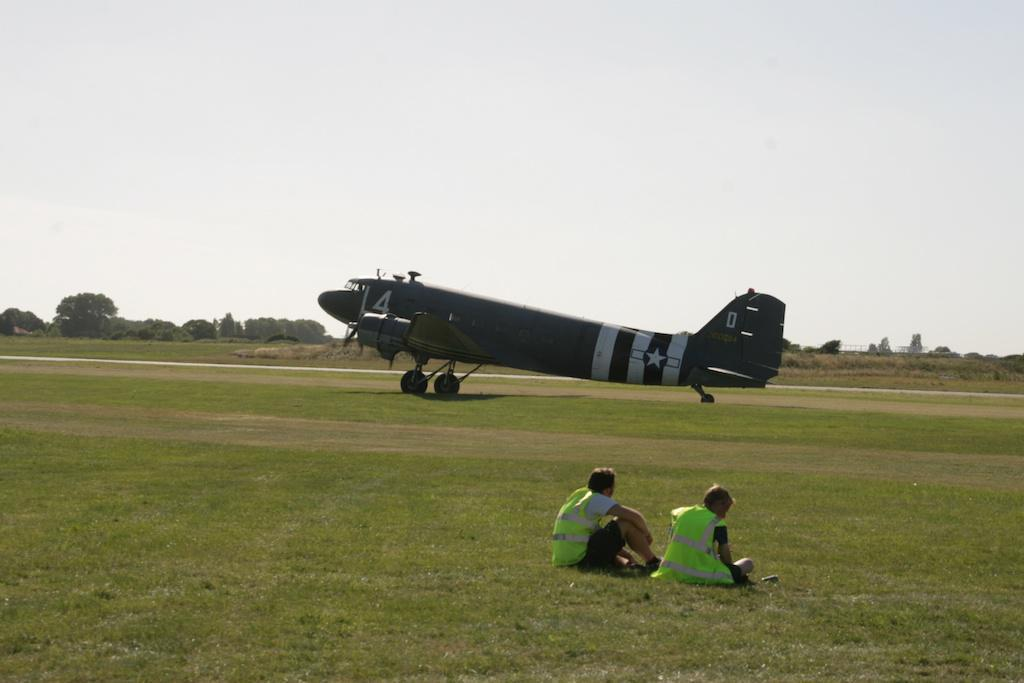What is the main subject of the image? The main subject of the image is a flying jet. Can you describe the people in the image? There are two people sitting in the image, and they are wearing clothes. What type of natural environment is visible in the image? There is grass and trees visible in the image, which suggests a natural setting. What is visible in the background of the image? The sky is visible in the image, which provides context for the time of day or weather conditions. What is the income of the leaf in the image? There is no leaf present in the image, and therefore no income can be attributed to it. 